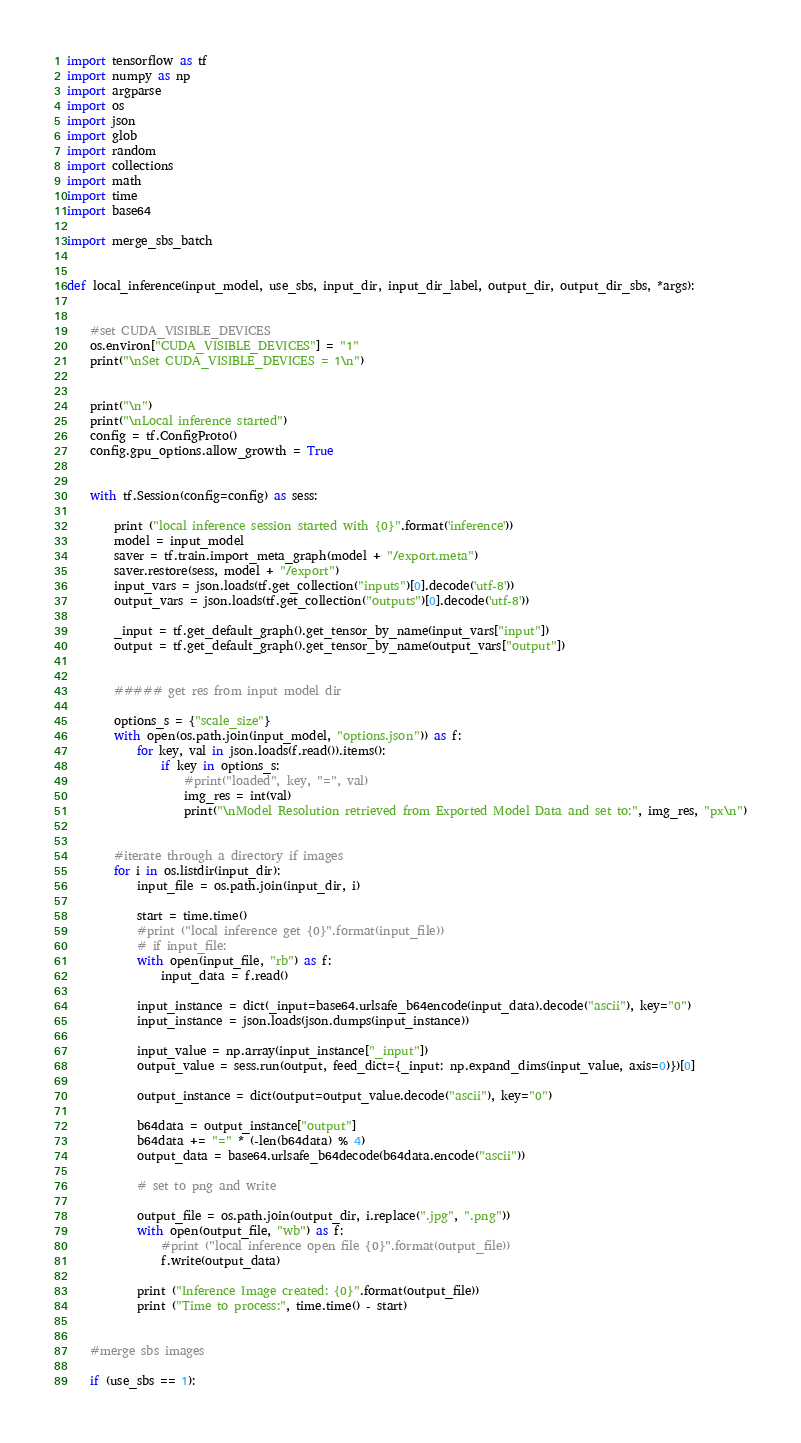<code> <loc_0><loc_0><loc_500><loc_500><_Python_>
import tensorflow as tf
import numpy as np
import argparse
import os
import json
import glob
import random
import collections
import math
import time
import base64

import merge_sbs_batch


def local_inference(input_model, use_sbs, input_dir, input_dir_label, output_dir, output_dir_sbs, *args):


    #set CUDA_VISIBLE_DEVICES
    os.environ["CUDA_VISIBLE_DEVICES"] = "1"
    print("\nSet CUDA_VISIBLE_DEVICES = 1\n")

    
    print("\n")
    print("\nLocal inference started")
    config = tf.ConfigProto()
    config.gpu_options.allow_growth = True


    with tf.Session(config=config) as sess:

        print ("local inference session started with {0}".format('inference'))
        model = input_model
        saver = tf.train.import_meta_graph(model + "/export.meta")
        saver.restore(sess, model + "/export")
        input_vars = json.loads(tf.get_collection("inputs")[0].decode('utf-8'))
        output_vars = json.loads(tf.get_collection("outputs")[0].decode('utf-8'))
        
        _input = tf.get_default_graph().get_tensor_by_name(input_vars["input"])
        output = tf.get_default_graph().get_tensor_by_name(output_vars["output"])


        ##### get res from input model dir

        options_s = {"scale_size"}
        with open(os.path.join(input_model, "options.json")) as f:
            for key, val in json.loads(f.read()).items():
                if key in options_s:
                    #print("loaded", key, "=", val)
                    img_res = int(val)
                    print("\nModel Resolution retrieved from Exported Model Data and set to:", img_res, "px\n")


        #iterate through a directory if images
        for i in os.listdir(input_dir):
            input_file = os.path.join(input_dir, i)

            start = time.time()
            #print ("local inference get {0}".format(input_file))
            # if input_file:
            with open(input_file, "rb") as f:
                input_data = f.read()

            input_instance = dict(_input=base64.urlsafe_b64encode(input_data).decode("ascii"), key="0")
            input_instance = json.loads(json.dumps(input_instance))

            input_value = np.array(input_instance["_input"])
            output_value = sess.run(output, feed_dict={_input: np.expand_dims(input_value, axis=0)})[0]

            output_instance = dict(output=output_value.decode("ascii"), key="0")
        
            b64data = output_instance["output"]
            b64data += "=" * (-len(b64data) % 4)
            output_data = base64.urlsafe_b64decode(b64data.encode("ascii"))
            
            # set to png and write 

            output_file = os.path.join(output_dir, i.replace(".jpg", ".png"))
            with open(output_file, "wb") as f:
                #print ("local inference open file {0}".format(output_file))
                f.write(output_data)

            print ("Inference Image created: {0}".format(output_file))
            print ("Time to process:", time.time() - start)


    #merge sbs images

    if (use_sbs == 1):</code> 